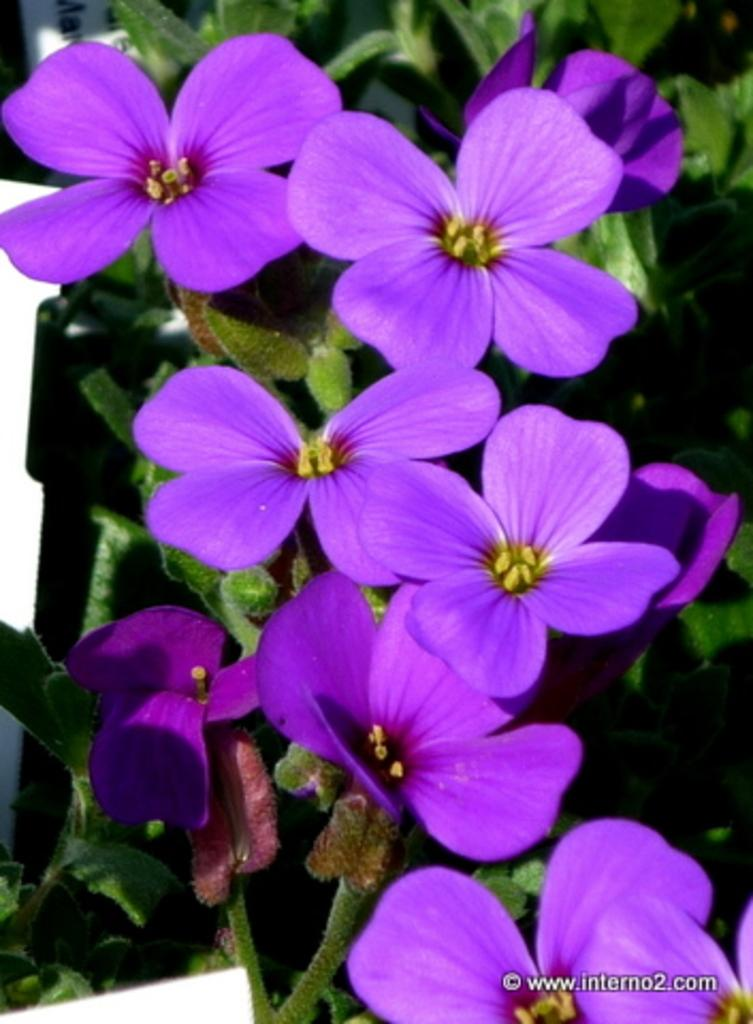What color are the flowers on the plants in the image? The flowers on the plants are purple. What else can be seen in the image besides the flowers? There is a board with some text in the image. How does the friction affect the movement of the goldfish in the image? There are no goldfish present in the image, so friction does not affect any movement. 